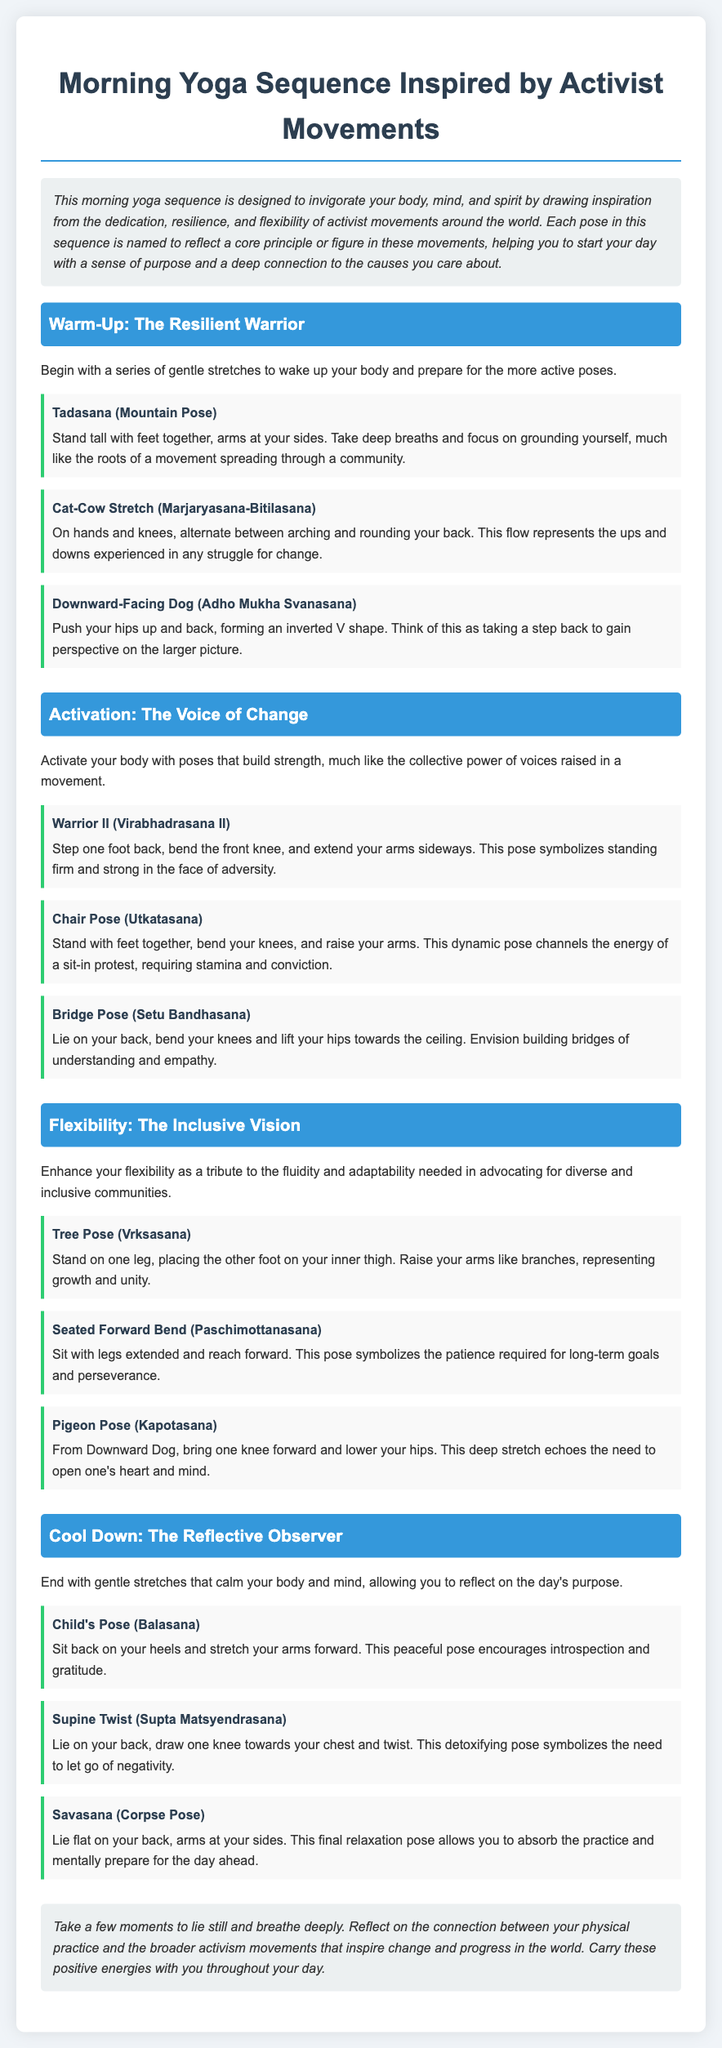What is the title of the document? The title of the document, as stated at the top, is "Morning Yoga Sequence Inspired by Activist Movements."
Answer: Morning Yoga Sequence Inspired by Activist Movements What does the introduction emphasize? The introduction emphasizes invigorating the body, mind, and spirit by drawing inspiration from activist movements' dedication, resilience, and flexibility.
Answer: Invigorate your body, mind, and spirit How many sections are in the workout plan? The workout plan contains four sections: Warm-Up, Activation, Flexibility, and Cool Down.
Answer: Four What pose is associated with standing firm in the face of adversity? The pose that symbolizes standing firm in the face of adversity is Warrior II.
Answer: Warrior II Which pose symbolizes patience required for long-term goals? The pose that symbolizes patience is Seated Forward Bend.
Answer: Seated Forward Bend What is the last pose in the cool-down section? The last pose in the cool-down section is Savasana.
Answer: Savasana What does the Child's Pose encourage? Child's Pose encourages introspection and gratitude.
Answer: Introspection and gratitude What does the Bridge Pose symbolize? The Bridge Pose symbolizes building bridges of understanding and empathy.
Answer: Building bridges of understanding and empathy What is the purpose of the closing section? The closing section is meant for reflecting on the connection between physical practice and activism movements.
Answer: Reflecting on the connection 